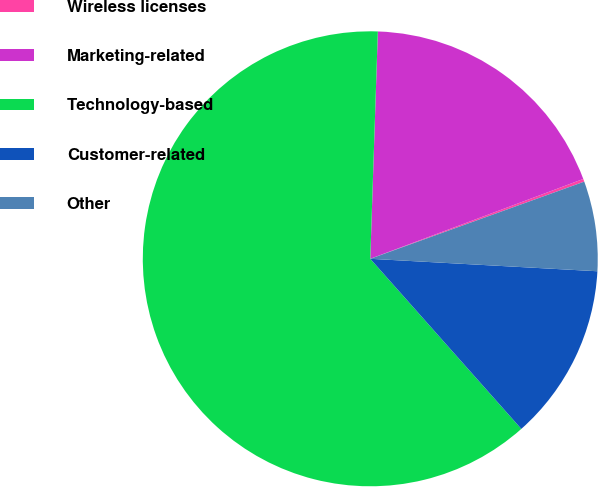Convert chart to OTSL. <chart><loc_0><loc_0><loc_500><loc_500><pie_chart><fcel>Wireless licenses<fcel>Marketing-related<fcel>Technology-based<fcel>Customer-related<fcel>Other<nl><fcel>0.2%<fcel>18.76%<fcel>62.08%<fcel>12.57%<fcel>6.38%<nl></chart> 